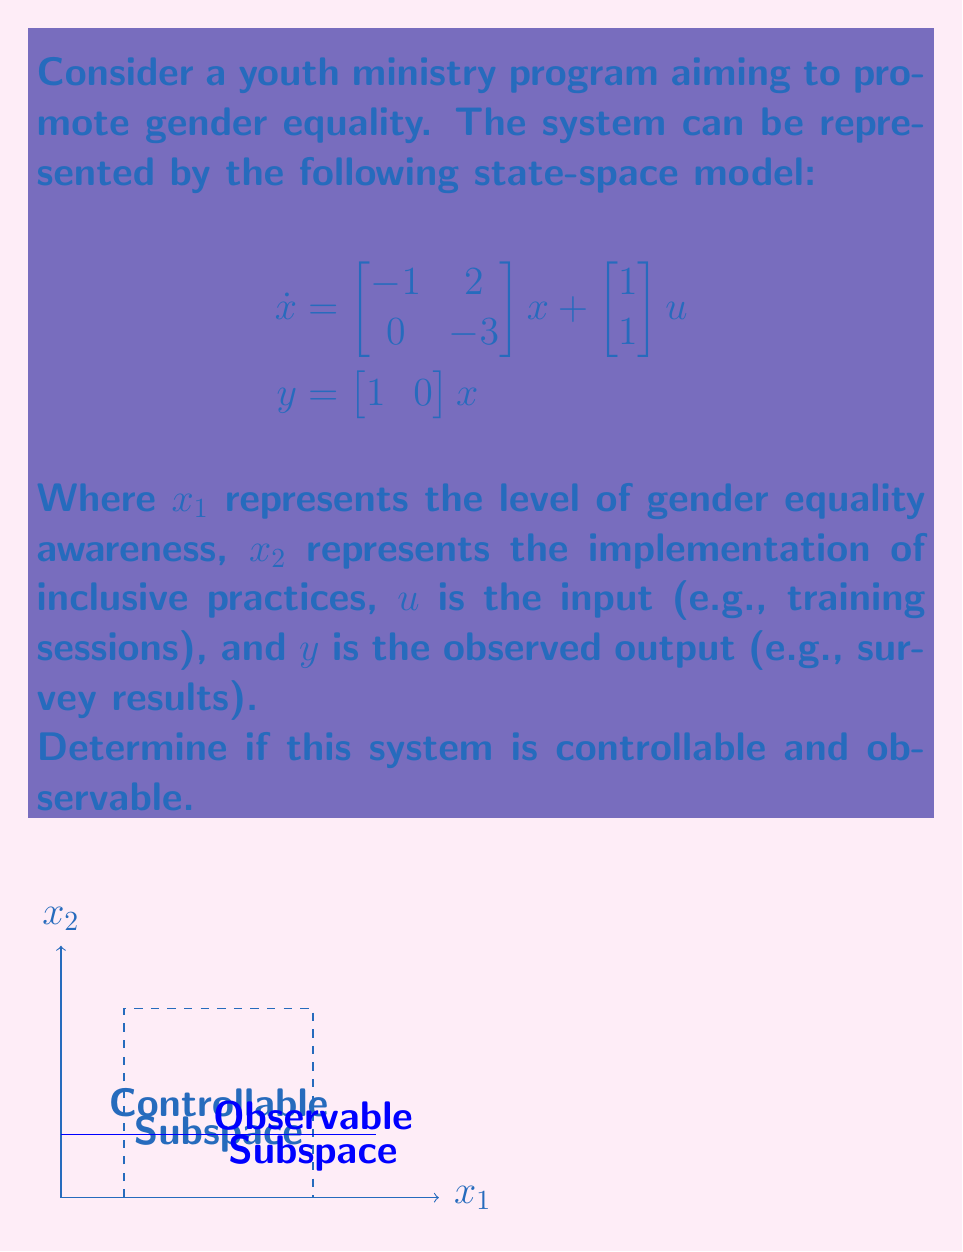What is the answer to this math problem? To determine controllability and observability, we need to check the ranks of the controllability and observability matrices.

1. Controllability:
   The controllability matrix is given by $C = [B \quad AB]$
   
   $$\begin{aligned}
   B &= \begin{bmatrix} 1 \\ 1 \end{bmatrix} \\
   AB &= \begin{bmatrix} -1 & 2 \\ 0 & -3 \end{bmatrix}\begin{bmatrix} 1 \\ 1 \end{bmatrix} = \begin{bmatrix} 1 \\ -3 \end{bmatrix}
   \end{aligned}$$

   Therefore, $C = \begin{bmatrix} 1 & 1 \\ 1 & -3 \end{bmatrix}$

   The determinant of $C$ is $1(-3) - 1(1) = -4 \neq 0$, so $C$ has full rank.

2. Observability:
   The observability matrix is given by $O = \begin{bmatrix} C \\ CA \end{bmatrix}$
   
   $$\begin{aligned}
   C &= \begin{bmatrix} 1 & 0 \end{bmatrix} \\
   CA &= \begin{bmatrix} 1 & 0 \end{bmatrix}\begin{bmatrix} -1 & 2 \\ 0 & -3 \end{bmatrix} = \begin{bmatrix} -1 & 2 \end{bmatrix}
   \end{aligned}$$

   Therefore, $O = \begin{bmatrix} 1 & 0 \\ -1 & 2 \end{bmatrix}$

   The determinant of $O$ is $1(2) - 0(-1) = 2 \neq 0$, so $O$ has full rank.

Since both the controllability and observability matrices have full rank (rank 2), the system is both controllable and observable.
Answer: The system is controllable and observable. 